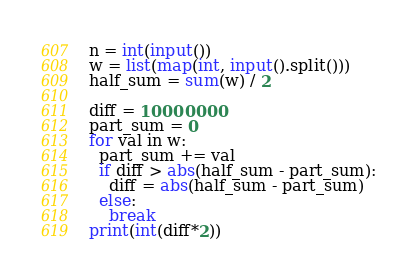Convert code to text. <code><loc_0><loc_0><loc_500><loc_500><_Python_>n = int(input())
w = list(map(int, input().split()))
half_sum = sum(w) / 2

diff = 10000000
part_sum = 0
for val in w:
  part_sum += val
  if diff > abs(half_sum - part_sum):
    diff = abs(half_sum - part_sum)
  else:
    break
print(int(diff*2))</code> 